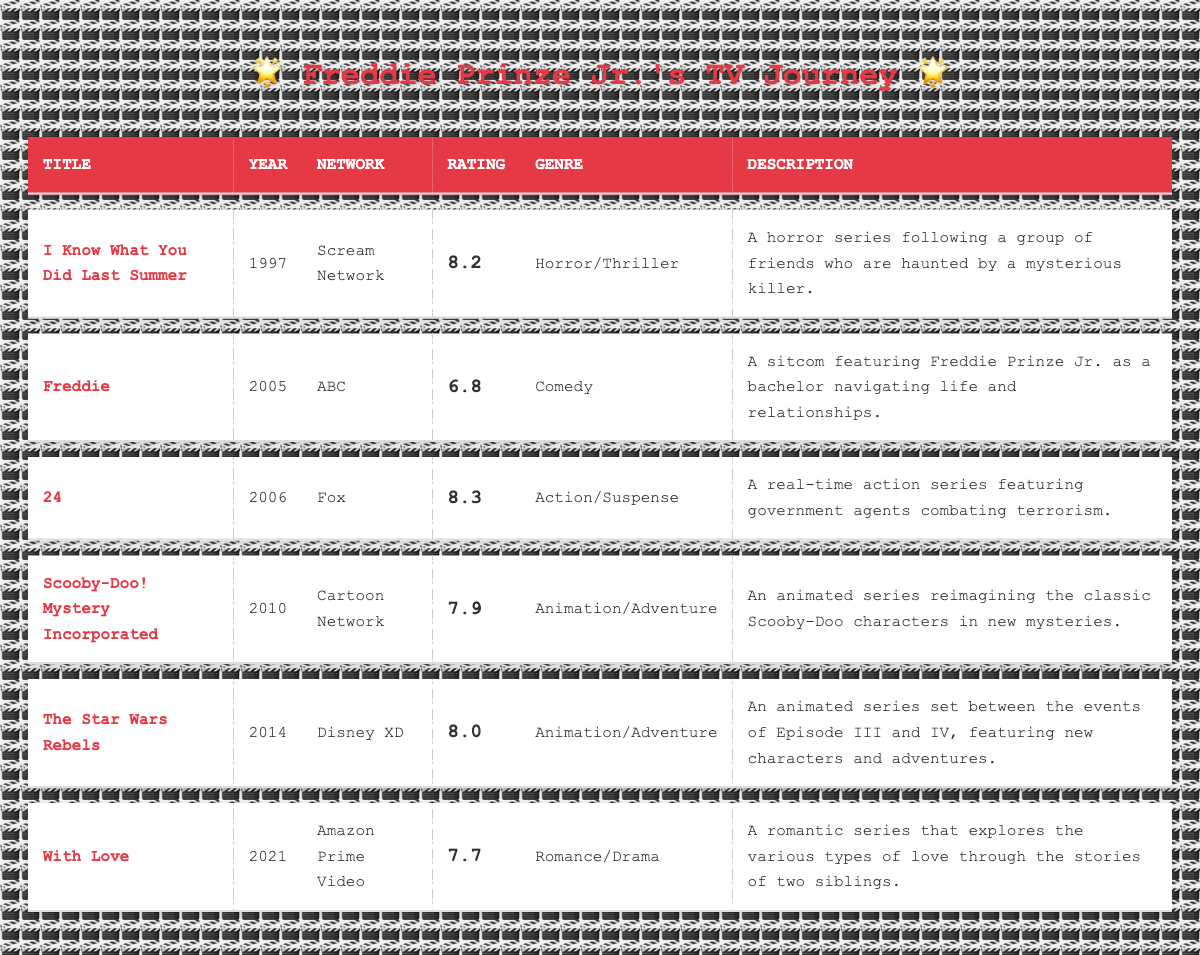What is the highest-rated show featuring Freddie Prinze Jr.? From the table, the highest rating is 8.3 for the show "24." I found this by scanning the ratings column, which shows "24" with a rating of 8.3 as the highest.
Answer: 24 Which show was released in 2010 and what is its rating? The show released in 2010 is "Scooby-Doo! Mystery Incorporated" and its rating is 7.9. I identified the year column to find 2010 and matched it with the corresponding ratings.
Answer: Scooby-Doo! Mystery Incorporated; 7.9 How many shows have ratings above 7.5? There are four shows with ratings above 7.5: "I Know What You Did Last Summer" (8.2), "24" (8.3), "Scooby-Doo! Mystery Incorporated" (7.9), and "The Star Wars Rebels" (8.0). I counted the ratings that were greater than 7.5 in the table.
Answer: 4 Is "With Love" rated higher than "Freddie"? Yes, "With Love" is rated 7.7, which is higher than "Freddie," which has a rating of 6.8. I compared the ratings for both shows in the ratings column.
Answer: Yes What is the average rating of all the shows featured in the table? To find the average rating, I first summed up all the ratings: 8.2 + 6.8 + 8.3 + 7.9 + 8.0 + 7.7 = 47.9. Then, there were 6 shows, so the average is 47.9 / 6 ≈ 7.98. I performed these calculations step by step using the ratings.
Answer: 7.98 Which genre has the most shows represented in the table? The genres represented are Horror/Thriller, Comedy, Action/Suspense, Animation/Adventure, and Romance/Drama. The genre Animation/Adventure has 2 shows ("Scooby-Doo! Mystery Incorporated" and "The Star Wars Rebels"), while the others each have 1 show, making Animation/Adventure the most represented genre. I counted each genre’s occurrences to determine this.
Answer: Animation/Adventure How many years apart are "Freddie" and "With Love"? "Freddie" was released in 2005, and "With Love" was released in 2021. The difference between these years is 2021 - 2005 = 16 years. I subtracted the release years to find the difference.
Answer: 16 years Has Freddie Prinze Jr. featured in more shows between 2000 and 2010 or between 2010 and 2021? Between 2000 and 2010, there are two shows ("Freddie" and "Scooby-Doo! Mystery Incorporated"). Between 2010 and 2021, there are two shows ("The Star Wars Rebels" and "With Love"). Both decades have an equal number of shows, so neither decade has more. I compared the counts of shows in each time range.
Answer: Neither; both have 2 shows 